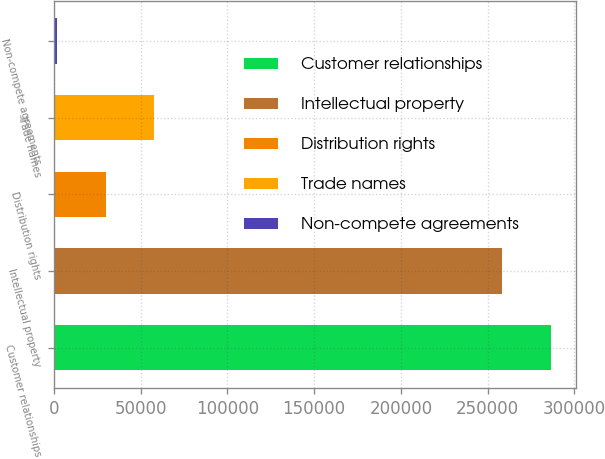Convert chart to OTSL. <chart><loc_0><loc_0><loc_500><loc_500><bar_chart><fcel>Customer relationships<fcel>Intellectual property<fcel>Distribution rights<fcel>Trade names<fcel>Non-compete agreements<nl><fcel>286509<fcel>258580<fcel>29904.7<fcel>57833.4<fcel>1976<nl></chart> 